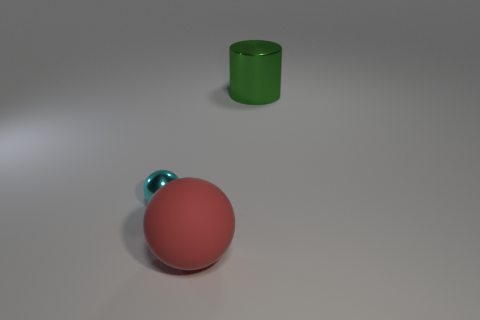Add 1 small brown rubber cubes. How many objects exist? 4 Subtract all spheres. How many objects are left? 1 Subtract 0 brown balls. How many objects are left? 3 Subtract all cyan balls. Subtract all big red metallic blocks. How many objects are left? 2 Add 2 large red spheres. How many large red spheres are left? 3 Add 2 tiny green matte cubes. How many tiny green matte cubes exist? 2 